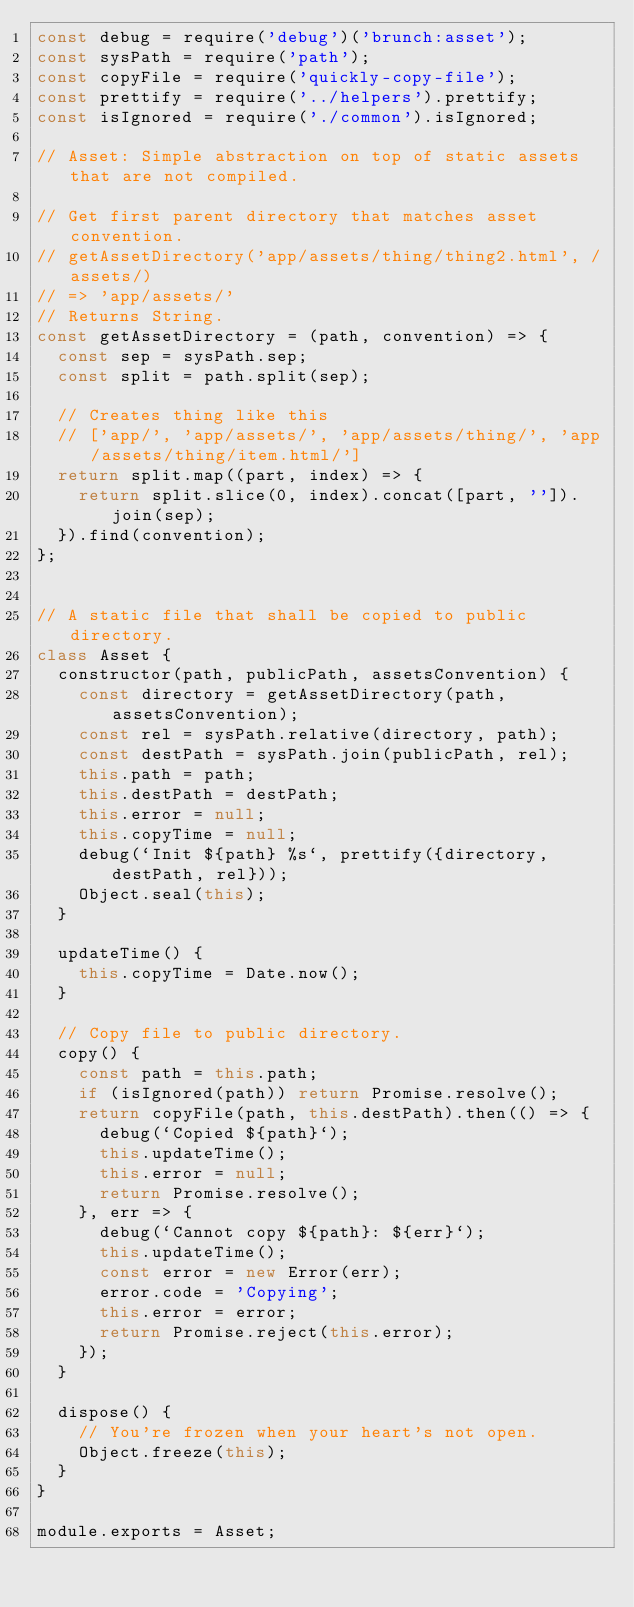Convert code to text. <code><loc_0><loc_0><loc_500><loc_500><_JavaScript_>const debug = require('debug')('brunch:asset');
const sysPath = require('path');
const copyFile = require('quickly-copy-file');
const prettify = require('../helpers').prettify;
const isIgnored = require('./common').isIgnored;

// Asset: Simple abstraction on top of static assets that are not compiled.

// Get first parent directory that matches asset convention.
// getAssetDirectory('app/assets/thing/thing2.html', /assets/)
// => 'app/assets/'
// Returns String.
const getAssetDirectory = (path, convention) => {
  const sep = sysPath.sep;
  const split = path.split(sep);

  // Creates thing like this
  // ['app/', 'app/assets/', 'app/assets/thing/', 'app/assets/thing/item.html/']
  return split.map((part, index) => {
    return split.slice(0, index).concat([part, '']).join(sep);
  }).find(convention);
};


// A static file that shall be copied to public directory.
class Asset {
  constructor(path, publicPath, assetsConvention) {
    const directory = getAssetDirectory(path, assetsConvention);
    const rel = sysPath.relative(directory, path);
    const destPath = sysPath.join(publicPath, rel);
    this.path = path;
    this.destPath = destPath;
    this.error = null;
    this.copyTime = null;
    debug(`Init ${path} %s`, prettify({directory, destPath, rel}));
    Object.seal(this);
  }

  updateTime() {
    this.copyTime = Date.now();
  }

  // Copy file to public directory.
  copy() {
    const path = this.path;
    if (isIgnored(path)) return Promise.resolve();
    return copyFile(path, this.destPath).then(() => {
      debug(`Copied ${path}`);
      this.updateTime();
      this.error = null;
      return Promise.resolve();
    }, err => {
      debug(`Cannot copy ${path}: ${err}`);
      this.updateTime();
      const error = new Error(err);
      error.code = 'Copying';
      this.error = error;
      return Promise.reject(this.error);
    });
  }

  dispose() {
    // You're frozen when your heart's not open.
    Object.freeze(this);
  }
}

module.exports = Asset;
</code> 